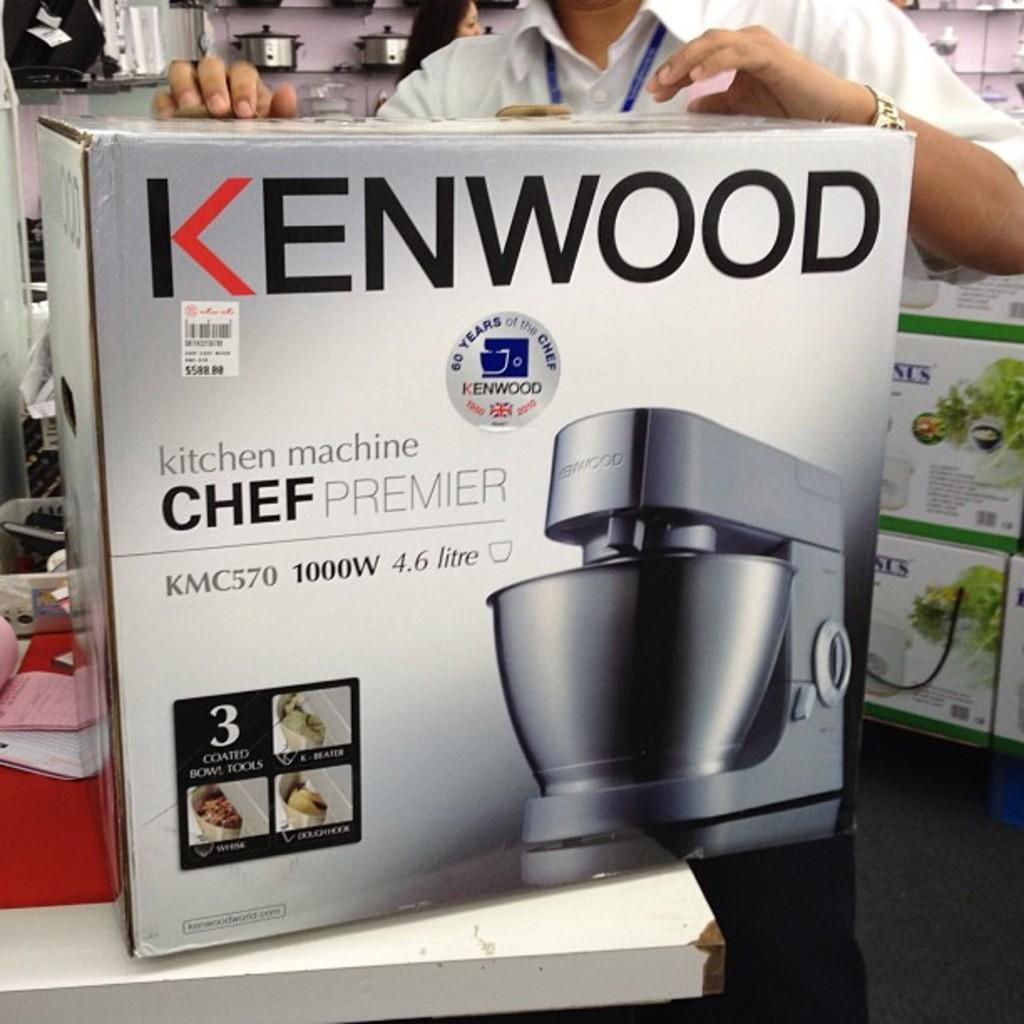Provide a one-sentence caption for the provided image. A Kenwood chef premier mixer is proudly displayed. 